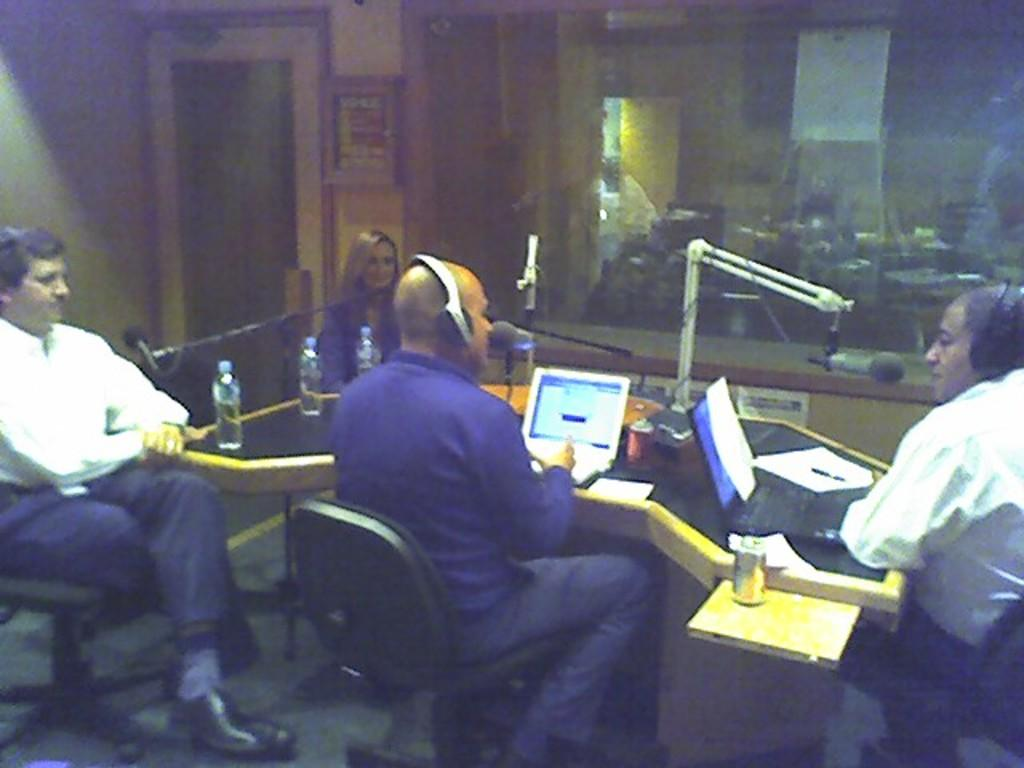What are the people in the image doing? The people in the image are seated on chairs. What can be seen on the heads of some men in the image? Some men in the image are wearing headsets. What electronic devices are present on the table in the image? There are laptops on the table in the image. What type of beverage containers are visible in the image? There are water bottles in the image. What devices are used for amplifying sound in the image? There are microphones in the image. Is there a flower arrangement on the table in the image? There is no flower arrangement present in the image. Is the scene taking place during a rainy day? The image does not provide any information about the weather, so it cannot be determined if it is a rainy day. 